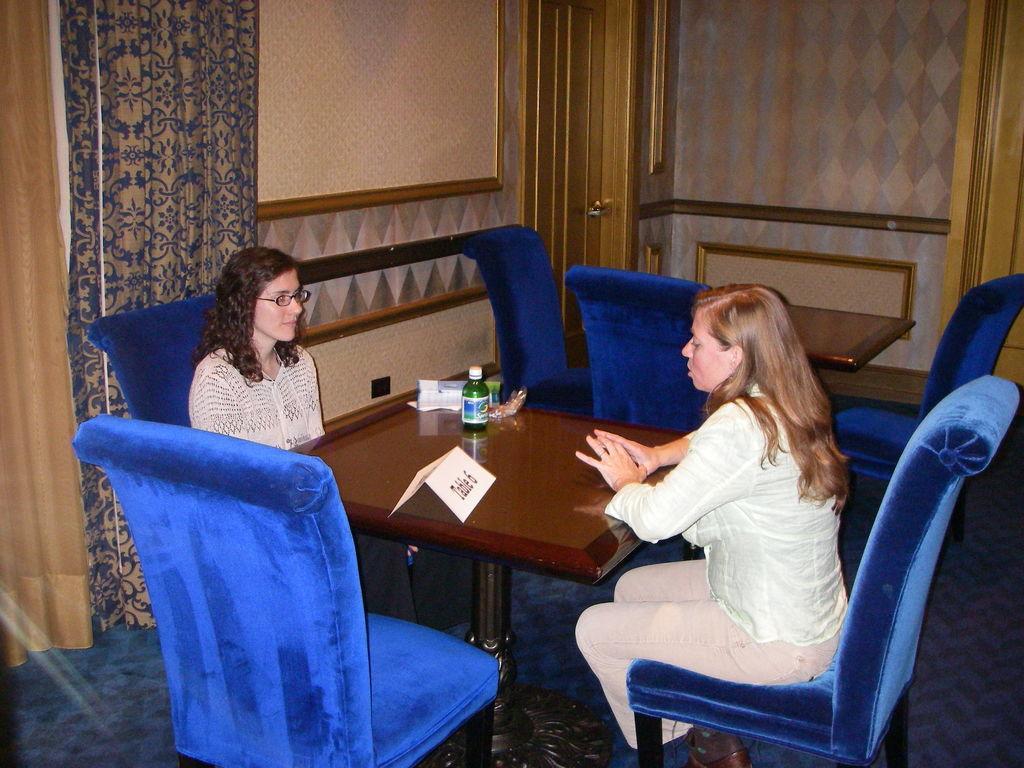How would you summarize this image in a sentence or two? In this image, two women are sat on the blue color chair. At the middle of the image, we can see wooden table. There are few items are placed on it. At the background, we can see curtains, cream color wall, some wooden piece, door. And blue color floor. 